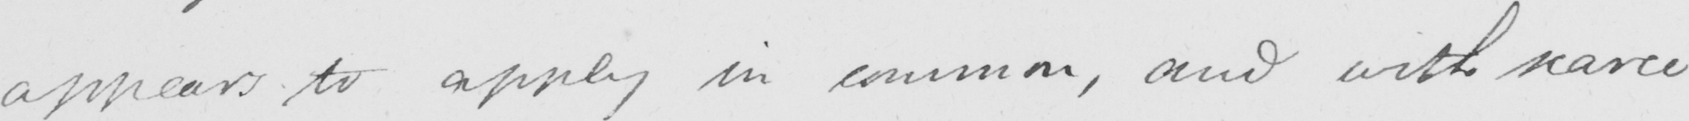What does this handwritten line say? appears to apply in common , and with scarce 